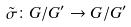Convert formula to latex. <formula><loc_0><loc_0><loc_500><loc_500>\tilde { \sigma } \colon G / G ^ { \prime } \rightarrow G / G ^ { \prime }</formula> 